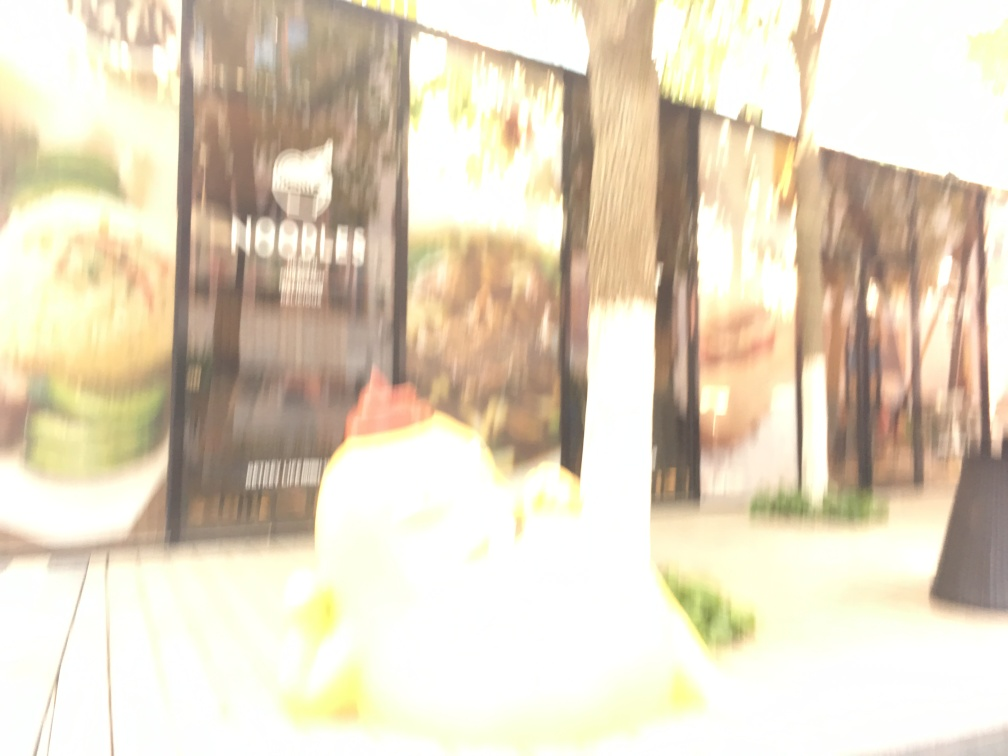What is the problem with the image quality?
A. Properly exposed and detailed.
B. Overexposed and blurry.
C. Underexposed and sharp.
Answer with the option's letter from the given choices directly.
 B. 